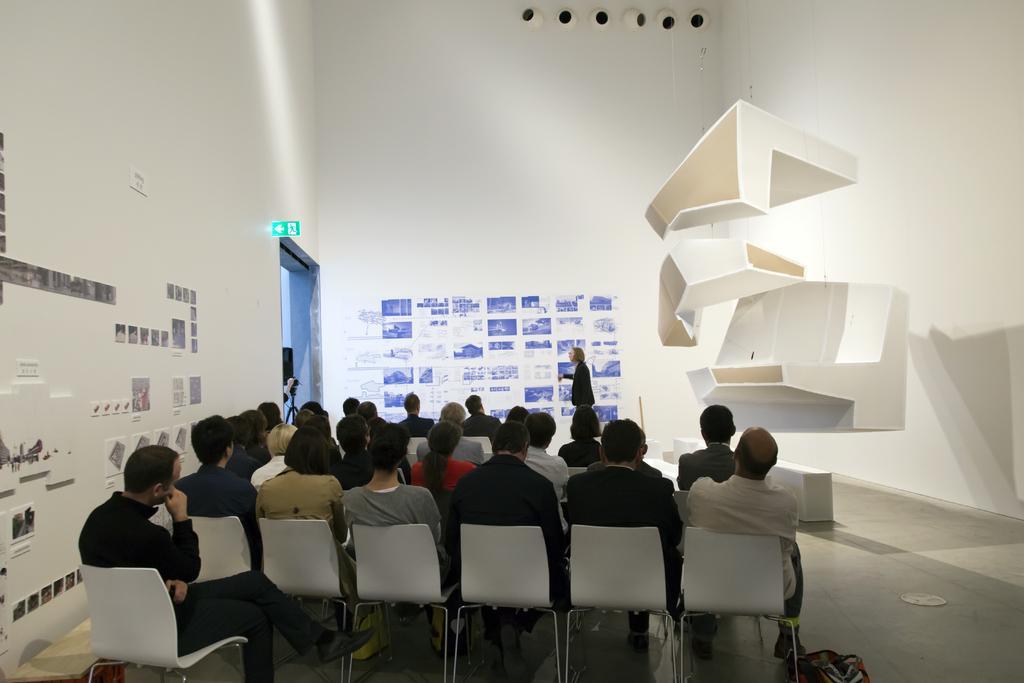Describe this image in one or two sentences. The picture is inside a room ,the people are sitting on the chair, to the right side there is art of white color ,the left side there is a presentation a woman standing in front of it and explaining ,to the left there is exit room in the background there is a white color wall. 